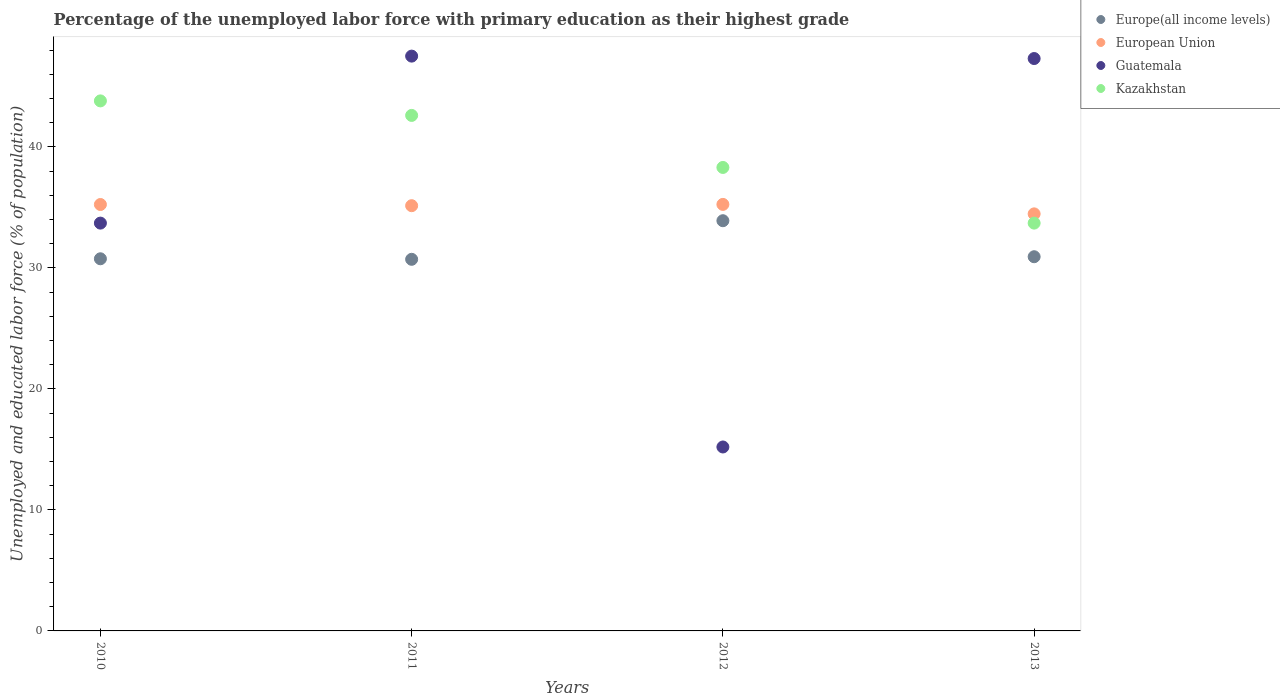How many different coloured dotlines are there?
Provide a succinct answer. 4. What is the percentage of the unemployed labor force with primary education in Kazakhstan in 2010?
Provide a short and direct response. 43.8. Across all years, what is the maximum percentage of the unemployed labor force with primary education in Guatemala?
Ensure brevity in your answer.  47.5. Across all years, what is the minimum percentage of the unemployed labor force with primary education in European Union?
Make the answer very short. 34.46. In which year was the percentage of the unemployed labor force with primary education in Guatemala minimum?
Keep it short and to the point. 2012. What is the total percentage of the unemployed labor force with primary education in Guatemala in the graph?
Provide a succinct answer. 143.7. What is the difference between the percentage of the unemployed labor force with primary education in Kazakhstan in 2011 and that in 2012?
Make the answer very short. 4.3. What is the difference between the percentage of the unemployed labor force with primary education in Europe(all income levels) in 2011 and the percentage of the unemployed labor force with primary education in Kazakhstan in 2012?
Ensure brevity in your answer.  -7.59. What is the average percentage of the unemployed labor force with primary education in European Union per year?
Make the answer very short. 35.02. In the year 2010, what is the difference between the percentage of the unemployed labor force with primary education in European Union and percentage of the unemployed labor force with primary education in Guatemala?
Your response must be concise. 1.54. What is the ratio of the percentage of the unemployed labor force with primary education in Europe(all income levels) in 2010 to that in 2011?
Provide a succinct answer. 1. Is the percentage of the unemployed labor force with primary education in European Union in 2010 less than that in 2013?
Give a very brief answer. No. Is the difference between the percentage of the unemployed labor force with primary education in European Union in 2012 and 2013 greater than the difference between the percentage of the unemployed labor force with primary education in Guatemala in 2012 and 2013?
Your response must be concise. Yes. What is the difference between the highest and the second highest percentage of the unemployed labor force with primary education in Kazakhstan?
Your response must be concise. 1.2. What is the difference between the highest and the lowest percentage of the unemployed labor force with primary education in European Union?
Your answer should be compact. 0.78. In how many years, is the percentage of the unemployed labor force with primary education in Kazakhstan greater than the average percentage of the unemployed labor force with primary education in Kazakhstan taken over all years?
Give a very brief answer. 2. Is the sum of the percentage of the unemployed labor force with primary education in Kazakhstan in 2010 and 2012 greater than the maximum percentage of the unemployed labor force with primary education in Guatemala across all years?
Ensure brevity in your answer.  Yes. Does the percentage of the unemployed labor force with primary education in Europe(all income levels) monotonically increase over the years?
Provide a succinct answer. No. Is the percentage of the unemployed labor force with primary education in European Union strictly less than the percentage of the unemployed labor force with primary education in Guatemala over the years?
Your response must be concise. No. Are the values on the major ticks of Y-axis written in scientific E-notation?
Your answer should be compact. No. What is the title of the graph?
Your answer should be compact. Percentage of the unemployed labor force with primary education as their highest grade. Does "United Arab Emirates" appear as one of the legend labels in the graph?
Give a very brief answer. No. What is the label or title of the X-axis?
Keep it short and to the point. Years. What is the label or title of the Y-axis?
Keep it short and to the point. Unemployed and educated labor force (% of population). What is the Unemployed and educated labor force (% of population) in Europe(all income levels) in 2010?
Your response must be concise. 30.75. What is the Unemployed and educated labor force (% of population) of European Union in 2010?
Your response must be concise. 35.24. What is the Unemployed and educated labor force (% of population) of Guatemala in 2010?
Offer a terse response. 33.7. What is the Unemployed and educated labor force (% of population) of Kazakhstan in 2010?
Provide a succinct answer. 43.8. What is the Unemployed and educated labor force (% of population) of Europe(all income levels) in 2011?
Keep it short and to the point. 30.71. What is the Unemployed and educated labor force (% of population) in European Union in 2011?
Your answer should be compact. 35.14. What is the Unemployed and educated labor force (% of population) in Guatemala in 2011?
Give a very brief answer. 47.5. What is the Unemployed and educated labor force (% of population) in Kazakhstan in 2011?
Your answer should be very brief. 42.6. What is the Unemployed and educated labor force (% of population) in Europe(all income levels) in 2012?
Your answer should be compact. 33.9. What is the Unemployed and educated labor force (% of population) in European Union in 2012?
Provide a short and direct response. 35.25. What is the Unemployed and educated labor force (% of population) of Guatemala in 2012?
Keep it short and to the point. 15.2. What is the Unemployed and educated labor force (% of population) of Kazakhstan in 2012?
Your answer should be compact. 38.3. What is the Unemployed and educated labor force (% of population) in Europe(all income levels) in 2013?
Your answer should be very brief. 30.92. What is the Unemployed and educated labor force (% of population) of European Union in 2013?
Ensure brevity in your answer.  34.46. What is the Unemployed and educated labor force (% of population) in Guatemala in 2013?
Provide a short and direct response. 47.3. What is the Unemployed and educated labor force (% of population) of Kazakhstan in 2013?
Your answer should be very brief. 33.7. Across all years, what is the maximum Unemployed and educated labor force (% of population) of Europe(all income levels)?
Ensure brevity in your answer.  33.9. Across all years, what is the maximum Unemployed and educated labor force (% of population) of European Union?
Make the answer very short. 35.25. Across all years, what is the maximum Unemployed and educated labor force (% of population) in Guatemala?
Offer a terse response. 47.5. Across all years, what is the maximum Unemployed and educated labor force (% of population) of Kazakhstan?
Offer a very short reply. 43.8. Across all years, what is the minimum Unemployed and educated labor force (% of population) of Europe(all income levels)?
Make the answer very short. 30.71. Across all years, what is the minimum Unemployed and educated labor force (% of population) in European Union?
Provide a succinct answer. 34.46. Across all years, what is the minimum Unemployed and educated labor force (% of population) of Guatemala?
Your answer should be compact. 15.2. Across all years, what is the minimum Unemployed and educated labor force (% of population) of Kazakhstan?
Offer a terse response. 33.7. What is the total Unemployed and educated labor force (% of population) of Europe(all income levels) in the graph?
Make the answer very short. 126.28. What is the total Unemployed and educated labor force (% of population) in European Union in the graph?
Provide a short and direct response. 140.09. What is the total Unemployed and educated labor force (% of population) of Guatemala in the graph?
Ensure brevity in your answer.  143.7. What is the total Unemployed and educated labor force (% of population) of Kazakhstan in the graph?
Provide a short and direct response. 158.4. What is the difference between the Unemployed and educated labor force (% of population) of Europe(all income levels) in 2010 and that in 2011?
Offer a terse response. 0.04. What is the difference between the Unemployed and educated labor force (% of population) of European Union in 2010 and that in 2011?
Offer a very short reply. 0.1. What is the difference between the Unemployed and educated labor force (% of population) in Kazakhstan in 2010 and that in 2011?
Offer a terse response. 1.2. What is the difference between the Unemployed and educated labor force (% of population) of Europe(all income levels) in 2010 and that in 2012?
Keep it short and to the point. -3.15. What is the difference between the Unemployed and educated labor force (% of population) in European Union in 2010 and that in 2012?
Provide a short and direct response. -0.01. What is the difference between the Unemployed and educated labor force (% of population) of Guatemala in 2010 and that in 2012?
Keep it short and to the point. 18.5. What is the difference between the Unemployed and educated labor force (% of population) in Europe(all income levels) in 2010 and that in 2013?
Keep it short and to the point. -0.17. What is the difference between the Unemployed and educated labor force (% of population) in European Union in 2010 and that in 2013?
Provide a short and direct response. 0.77. What is the difference between the Unemployed and educated labor force (% of population) in Kazakhstan in 2010 and that in 2013?
Your answer should be compact. 10.1. What is the difference between the Unemployed and educated labor force (% of population) of Europe(all income levels) in 2011 and that in 2012?
Your answer should be very brief. -3.19. What is the difference between the Unemployed and educated labor force (% of population) of European Union in 2011 and that in 2012?
Ensure brevity in your answer.  -0.11. What is the difference between the Unemployed and educated labor force (% of population) in Guatemala in 2011 and that in 2012?
Offer a terse response. 32.3. What is the difference between the Unemployed and educated labor force (% of population) in Europe(all income levels) in 2011 and that in 2013?
Your response must be concise. -0.21. What is the difference between the Unemployed and educated labor force (% of population) of European Union in 2011 and that in 2013?
Keep it short and to the point. 0.68. What is the difference between the Unemployed and educated labor force (% of population) in Guatemala in 2011 and that in 2013?
Ensure brevity in your answer.  0.2. What is the difference between the Unemployed and educated labor force (% of population) in Kazakhstan in 2011 and that in 2013?
Make the answer very short. 8.9. What is the difference between the Unemployed and educated labor force (% of population) in Europe(all income levels) in 2012 and that in 2013?
Keep it short and to the point. 2.98. What is the difference between the Unemployed and educated labor force (% of population) of European Union in 2012 and that in 2013?
Your answer should be very brief. 0.78. What is the difference between the Unemployed and educated labor force (% of population) of Guatemala in 2012 and that in 2013?
Your response must be concise. -32.1. What is the difference between the Unemployed and educated labor force (% of population) of Europe(all income levels) in 2010 and the Unemployed and educated labor force (% of population) of European Union in 2011?
Provide a succinct answer. -4.39. What is the difference between the Unemployed and educated labor force (% of population) in Europe(all income levels) in 2010 and the Unemployed and educated labor force (% of population) in Guatemala in 2011?
Provide a short and direct response. -16.75. What is the difference between the Unemployed and educated labor force (% of population) in Europe(all income levels) in 2010 and the Unemployed and educated labor force (% of population) in Kazakhstan in 2011?
Make the answer very short. -11.85. What is the difference between the Unemployed and educated labor force (% of population) in European Union in 2010 and the Unemployed and educated labor force (% of population) in Guatemala in 2011?
Provide a succinct answer. -12.26. What is the difference between the Unemployed and educated labor force (% of population) of European Union in 2010 and the Unemployed and educated labor force (% of population) of Kazakhstan in 2011?
Make the answer very short. -7.36. What is the difference between the Unemployed and educated labor force (% of population) of Europe(all income levels) in 2010 and the Unemployed and educated labor force (% of population) of European Union in 2012?
Provide a succinct answer. -4.49. What is the difference between the Unemployed and educated labor force (% of population) of Europe(all income levels) in 2010 and the Unemployed and educated labor force (% of population) of Guatemala in 2012?
Ensure brevity in your answer.  15.55. What is the difference between the Unemployed and educated labor force (% of population) of Europe(all income levels) in 2010 and the Unemployed and educated labor force (% of population) of Kazakhstan in 2012?
Give a very brief answer. -7.55. What is the difference between the Unemployed and educated labor force (% of population) of European Union in 2010 and the Unemployed and educated labor force (% of population) of Guatemala in 2012?
Your answer should be very brief. 20.04. What is the difference between the Unemployed and educated labor force (% of population) in European Union in 2010 and the Unemployed and educated labor force (% of population) in Kazakhstan in 2012?
Provide a succinct answer. -3.06. What is the difference between the Unemployed and educated labor force (% of population) in Europe(all income levels) in 2010 and the Unemployed and educated labor force (% of population) in European Union in 2013?
Ensure brevity in your answer.  -3.71. What is the difference between the Unemployed and educated labor force (% of population) of Europe(all income levels) in 2010 and the Unemployed and educated labor force (% of population) of Guatemala in 2013?
Ensure brevity in your answer.  -16.55. What is the difference between the Unemployed and educated labor force (% of population) of Europe(all income levels) in 2010 and the Unemployed and educated labor force (% of population) of Kazakhstan in 2013?
Provide a short and direct response. -2.95. What is the difference between the Unemployed and educated labor force (% of population) in European Union in 2010 and the Unemployed and educated labor force (% of population) in Guatemala in 2013?
Offer a very short reply. -12.06. What is the difference between the Unemployed and educated labor force (% of population) of European Union in 2010 and the Unemployed and educated labor force (% of population) of Kazakhstan in 2013?
Your answer should be compact. 1.54. What is the difference between the Unemployed and educated labor force (% of population) in Europe(all income levels) in 2011 and the Unemployed and educated labor force (% of population) in European Union in 2012?
Your answer should be very brief. -4.54. What is the difference between the Unemployed and educated labor force (% of population) in Europe(all income levels) in 2011 and the Unemployed and educated labor force (% of population) in Guatemala in 2012?
Your response must be concise. 15.51. What is the difference between the Unemployed and educated labor force (% of population) of Europe(all income levels) in 2011 and the Unemployed and educated labor force (% of population) of Kazakhstan in 2012?
Your answer should be compact. -7.59. What is the difference between the Unemployed and educated labor force (% of population) of European Union in 2011 and the Unemployed and educated labor force (% of population) of Guatemala in 2012?
Your response must be concise. 19.94. What is the difference between the Unemployed and educated labor force (% of population) of European Union in 2011 and the Unemployed and educated labor force (% of population) of Kazakhstan in 2012?
Keep it short and to the point. -3.16. What is the difference between the Unemployed and educated labor force (% of population) in Europe(all income levels) in 2011 and the Unemployed and educated labor force (% of population) in European Union in 2013?
Ensure brevity in your answer.  -3.76. What is the difference between the Unemployed and educated labor force (% of population) in Europe(all income levels) in 2011 and the Unemployed and educated labor force (% of population) in Guatemala in 2013?
Your response must be concise. -16.59. What is the difference between the Unemployed and educated labor force (% of population) of Europe(all income levels) in 2011 and the Unemployed and educated labor force (% of population) of Kazakhstan in 2013?
Your answer should be compact. -2.99. What is the difference between the Unemployed and educated labor force (% of population) in European Union in 2011 and the Unemployed and educated labor force (% of population) in Guatemala in 2013?
Provide a succinct answer. -12.16. What is the difference between the Unemployed and educated labor force (% of population) in European Union in 2011 and the Unemployed and educated labor force (% of population) in Kazakhstan in 2013?
Keep it short and to the point. 1.44. What is the difference between the Unemployed and educated labor force (% of population) of Europe(all income levels) in 2012 and the Unemployed and educated labor force (% of population) of European Union in 2013?
Keep it short and to the point. -0.57. What is the difference between the Unemployed and educated labor force (% of population) in Europe(all income levels) in 2012 and the Unemployed and educated labor force (% of population) in Guatemala in 2013?
Give a very brief answer. -13.4. What is the difference between the Unemployed and educated labor force (% of population) of Europe(all income levels) in 2012 and the Unemployed and educated labor force (% of population) of Kazakhstan in 2013?
Offer a very short reply. 0.2. What is the difference between the Unemployed and educated labor force (% of population) of European Union in 2012 and the Unemployed and educated labor force (% of population) of Guatemala in 2013?
Ensure brevity in your answer.  -12.05. What is the difference between the Unemployed and educated labor force (% of population) of European Union in 2012 and the Unemployed and educated labor force (% of population) of Kazakhstan in 2013?
Offer a very short reply. 1.55. What is the difference between the Unemployed and educated labor force (% of population) of Guatemala in 2012 and the Unemployed and educated labor force (% of population) of Kazakhstan in 2013?
Give a very brief answer. -18.5. What is the average Unemployed and educated labor force (% of population) in Europe(all income levels) per year?
Your response must be concise. 31.57. What is the average Unemployed and educated labor force (% of population) of European Union per year?
Give a very brief answer. 35.02. What is the average Unemployed and educated labor force (% of population) of Guatemala per year?
Offer a terse response. 35.92. What is the average Unemployed and educated labor force (% of population) in Kazakhstan per year?
Keep it short and to the point. 39.6. In the year 2010, what is the difference between the Unemployed and educated labor force (% of population) of Europe(all income levels) and Unemployed and educated labor force (% of population) of European Union?
Provide a short and direct response. -4.49. In the year 2010, what is the difference between the Unemployed and educated labor force (% of population) in Europe(all income levels) and Unemployed and educated labor force (% of population) in Guatemala?
Offer a very short reply. -2.95. In the year 2010, what is the difference between the Unemployed and educated labor force (% of population) in Europe(all income levels) and Unemployed and educated labor force (% of population) in Kazakhstan?
Offer a very short reply. -13.05. In the year 2010, what is the difference between the Unemployed and educated labor force (% of population) of European Union and Unemployed and educated labor force (% of population) of Guatemala?
Provide a short and direct response. 1.54. In the year 2010, what is the difference between the Unemployed and educated labor force (% of population) of European Union and Unemployed and educated labor force (% of population) of Kazakhstan?
Make the answer very short. -8.56. In the year 2011, what is the difference between the Unemployed and educated labor force (% of population) of Europe(all income levels) and Unemployed and educated labor force (% of population) of European Union?
Give a very brief answer. -4.43. In the year 2011, what is the difference between the Unemployed and educated labor force (% of population) in Europe(all income levels) and Unemployed and educated labor force (% of population) in Guatemala?
Your answer should be very brief. -16.79. In the year 2011, what is the difference between the Unemployed and educated labor force (% of population) of Europe(all income levels) and Unemployed and educated labor force (% of population) of Kazakhstan?
Ensure brevity in your answer.  -11.89. In the year 2011, what is the difference between the Unemployed and educated labor force (% of population) in European Union and Unemployed and educated labor force (% of population) in Guatemala?
Provide a succinct answer. -12.36. In the year 2011, what is the difference between the Unemployed and educated labor force (% of population) in European Union and Unemployed and educated labor force (% of population) in Kazakhstan?
Give a very brief answer. -7.46. In the year 2011, what is the difference between the Unemployed and educated labor force (% of population) in Guatemala and Unemployed and educated labor force (% of population) in Kazakhstan?
Your answer should be compact. 4.9. In the year 2012, what is the difference between the Unemployed and educated labor force (% of population) in Europe(all income levels) and Unemployed and educated labor force (% of population) in European Union?
Give a very brief answer. -1.35. In the year 2012, what is the difference between the Unemployed and educated labor force (% of population) in Europe(all income levels) and Unemployed and educated labor force (% of population) in Guatemala?
Offer a terse response. 18.7. In the year 2012, what is the difference between the Unemployed and educated labor force (% of population) of Europe(all income levels) and Unemployed and educated labor force (% of population) of Kazakhstan?
Provide a short and direct response. -4.4. In the year 2012, what is the difference between the Unemployed and educated labor force (% of population) of European Union and Unemployed and educated labor force (% of population) of Guatemala?
Give a very brief answer. 20.05. In the year 2012, what is the difference between the Unemployed and educated labor force (% of population) in European Union and Unemployed and educated labor force (% of population) in Kazakhstan?
Provide a short and direct response. -3.05. In the year 2012, what is the difference between the Unemployed and educated labor force (% of population) of Guatemala and Unemployed and educated labor force (% of population) of Kazakhstan?
Provide a short and direct response. -23.1. In the year 2013, what is the difference between the Unemployed and educated labor force (% of population) in Europe(all income levels) and Unemployed and educated labor force (% of population) in European Union?
Provide a succinct answer. -3.54. In the year 2013, what is the difference between the Unemployed and educated labor force (% of population) of Europe(all income levels) and Unemployed and educated labor force (% of population) of Guatemala?
Ensure brevity in your answer.  -16.38. In the year 2013, what is the difference between the Unemployed and educated labor force (% of population) in Europe(all income levels) and Unemployed and educated labor force (% of population) in Kazakhstan?
Make the answer very short. -2.78. In the year 2013, what is the difference between the Unemployed and educated labor force (% of population) in European Union and Unemployed and educated labor force (% of population) in Guatemala?
Your answer should be compact. -12.84. In the year 2013, what is the difference between the Unemployed and educated labor force (% of population) of European Union and Unemployed and educated labor force (% of population) of Kazakhstan?
Ensure brevity in your answer.  0.76. In the year 2013, what is the difference between the Unemployed and educated labor force (% of population) of Guatemala and Unemployed and educated labor force (% of population) of Kazakhstan?
Offer a terse response. 13.6. What is the ratio of the Unemployed and educated labor force (% of population) in Guatemala in 2010 to that in 2011?
Offer a terse response. 0.71. What is the ratio of the Unemployed and educated labor force (% of population) of Kazakhstan in 2010 to that in 2011?
Provide a short and direct response. 1.03. What is the ratio of the Unemployed and educated labor force (% of population) of Europe(all income levels) in 2010 to that in 2012?
Your response must be concise. 0.91. What is the ratio of the Unemployed and educated labor force (% of population) in European Union in 2010 to that in 2012?
Ensure brevity in your answer.  1. What is the ratio of the Unemployed and educated labor force (% of population) of Guatemala in 2010 to that in 2012?
Ensure brevity in your answer.  2.22. What is the ratio of the Unemployed and educated labor force (% of population) of Kazakhstan in 2010 to that in 2012?
Offer a terse response. 1.14. What is the ratio of the Unemployed and educated labor force (% of population) of European Union in 2010 to that in 2013?
Your response must be concise. 1.02. What is the ratio of the Unemployed and educated labor force (% of population) of Guatemala in 2010 to that in 2013?
Make the answer very short. 0.71. What is the ratio of the Unemployed and educated labor force (% of population) of Kazakhstan in 2010 to that in 2013?
Provide a succinct answer. 1.3. What is the ratio of the Unemployed and educated labor force (% of population) in Europe(all income levels) in 2011 to that in 2012?
Your answer should be compact. 0.91. What is the ratio of the Unemployed and educated labor force (% of population) of European Union in 2011 to that in 2012?
Ensure brevity in your answer.  1. What is the ratio of the Unemployed and educated labor force (% of population) of Guatemala in 2011 to that in 2012?
Provide a succinct answer. 3.12. What is the ratio of the Unemployed and educated labor force (% of population) of Kazakhstan in 2011 to that in 2012?
Provide a short and direct response. 1.11. What is the ratio of the Unemployed and educated labor force (% of population) of European Union in 2011 to that in 2013?
Your answer should be compact. 1.02. What is the ratio of the Unemployed and educated labor force (% of population) of Guatemala in 2011 to that in 2013?
Keep it short and to the point. 1. What is the ratio of the Unemployed and educated labor force (% of population) of Kazakhstan in 2011 to that in 2013?
Offer a very short reply. 1.26. What is the ratio of the Unemployed and educated labor force (% of population) in Europe(all income levels) in 2012 to that in 2013?
Offer a terse response. 1.1. What is the ratio of the Unemployed and educated labor force (% of population) of European Union in 2012 to that in 2013?
Offer a very short reply. 1.02. What is the ratio of the Unemployed and educated labor force (% of population) of Guatemala in 2012 to that in 2013?
Ensure brevity in your answer.  0.32. What is the ratio of the Unemployed and educated labor force (% of population) of Kazakhstan in 2012 to that in 2013?
Ensure brevity in your answer.  1.14. What is the difference between the highest and the second highest Unemployed and educated labor force (% of population) of Europe(all income levels)?
Provide a short and direct response. 2.98. What is the difference between the highest and the second highest Unemployed and educated labor force (% of population) of European Union?
Your response must be concise. 0.01. What is the difference between the highest and the second highest Unemployed and educated labor force (% of population) in Guatemala?
Offer a terse response. 0.2. What is the difference between the highest and the lowest Unemployed and educated labor force (% of population) of Europe(all income levels)?
Your answer should be compact. 3.19. What is the difference between the highest and the lowest Unemployed and educated labor force (% of population) of European Union?
Provide a short and direct response. 0.78. What is the difference between the highest and the lowest Unemployed and educated labor force (% of population) of Guatemala?
Ensure brevity in your answer.  32.3. What is the difference between the highest and the lowest Unemployed and educated labor force (% of population) of Kazakhstan?
Keep it short and to the point. 10.1. 